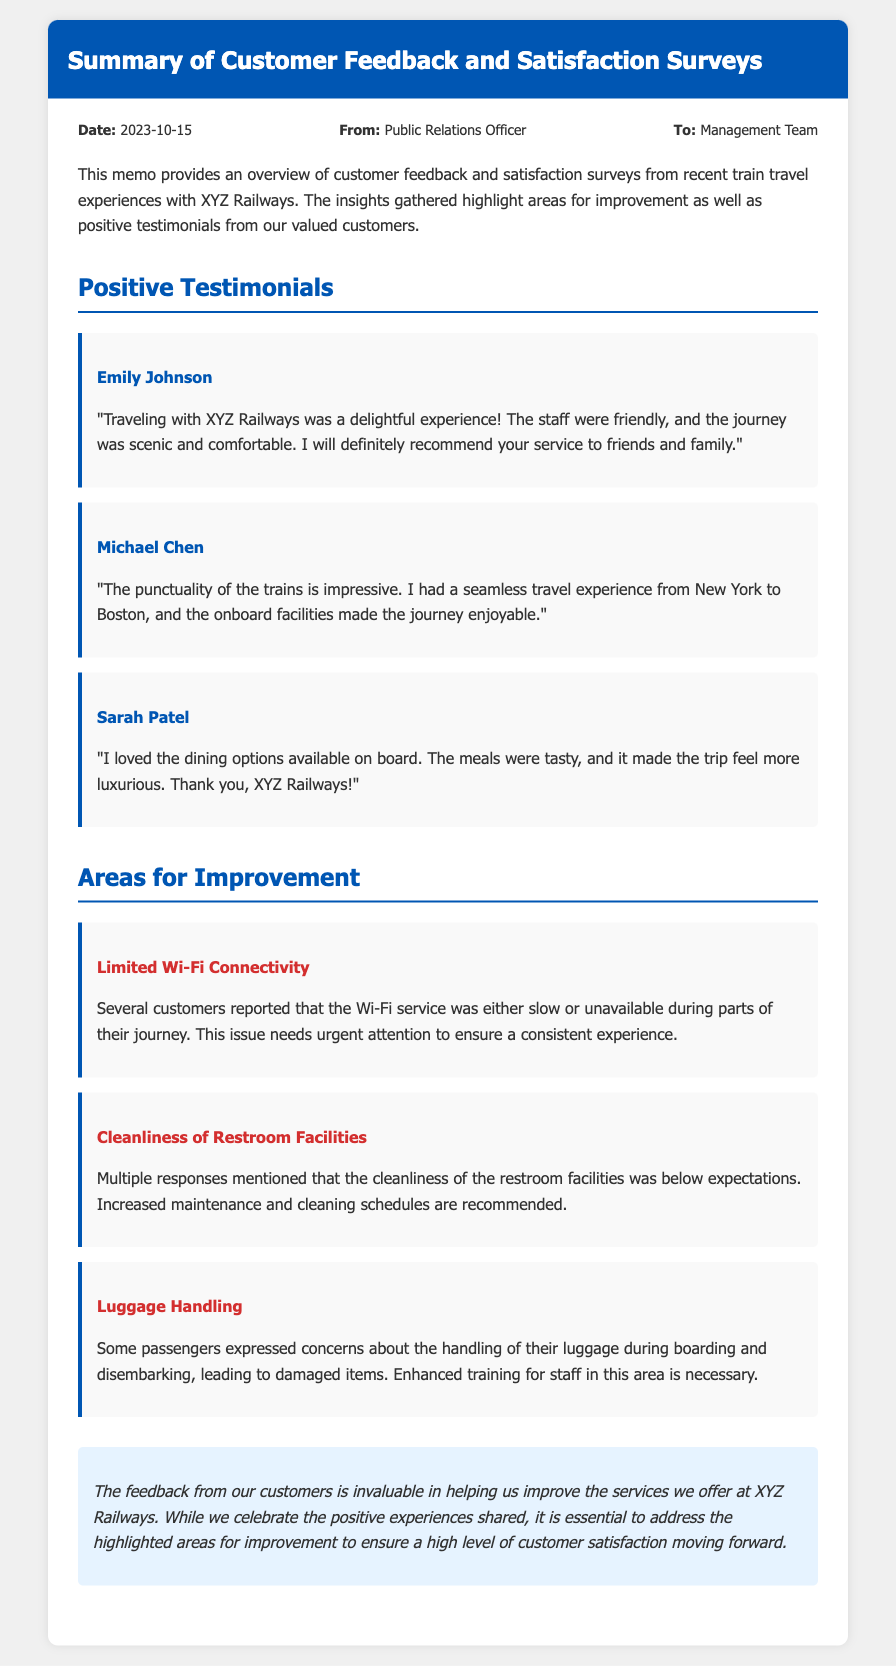What is the date of the memo? The date of the memo is mentioned in the document's meta section.
Answer: 2023-10-15 Who is the memo from? The memo indicates who authored it in the meta section.
Answer: Public Relations Officer What is one positive testimonial mentioned in the memo? The document contains several positive testimonials from customers.
Answer: "Traveling with XYZ Railways was a delightful experience!" What is one area for improvement highlighted in the memo? The document lists areas for improvement based on customer feedback.
Answer: Limited Wi-Fi Connectivity How many positive testimonials are shared in the memo? The number of testimonials can be counted in the relevant section.
Answer: Three What is the main focus of this memo? The purpose of the memo is specified in the introductory paragraph.
Answer: Customer feedback and satisfaction surveys What is the last section of the memo about? The last section summarizes the importance of the feedback gathered.
Answer: Conclusion Which customer praised the dining options? The testimonial section includes testimonials with specific customer names and experiences.
Answer: Sarah Patel What issue relates to luggage handling? The document mentions specific issues under areas for improvement.
Answer: Luggage Handling 